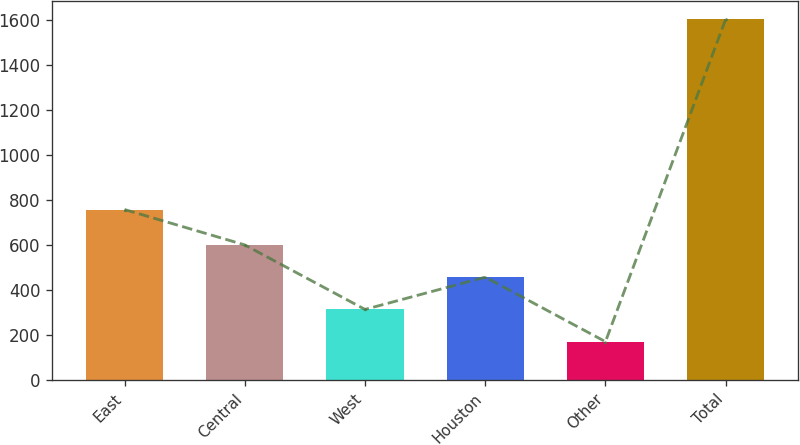<chart> <loc_0><loc_0><loc_500><loc_500><bar_chart><fcel>East<fcel>Central<fcel>West<fcel>Houston<fcel>Other<fcel>Total<nl><fcel>757<fcel>599.5<fcel>312.5<fcel>456<fcel>169<fcel>1604<nl></chart> 